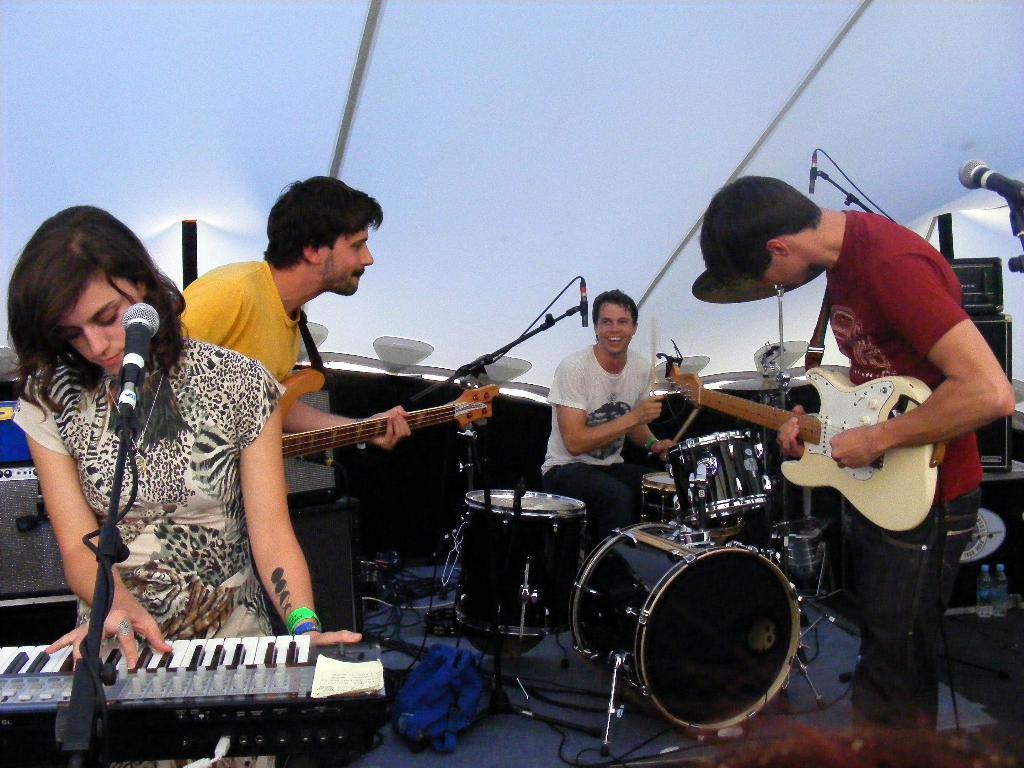Can you describe this image briefly? All the people in the picture are playing musical instruments , among them two are playing a guitar , a guy is playing drums and a lady is playing a piano. 